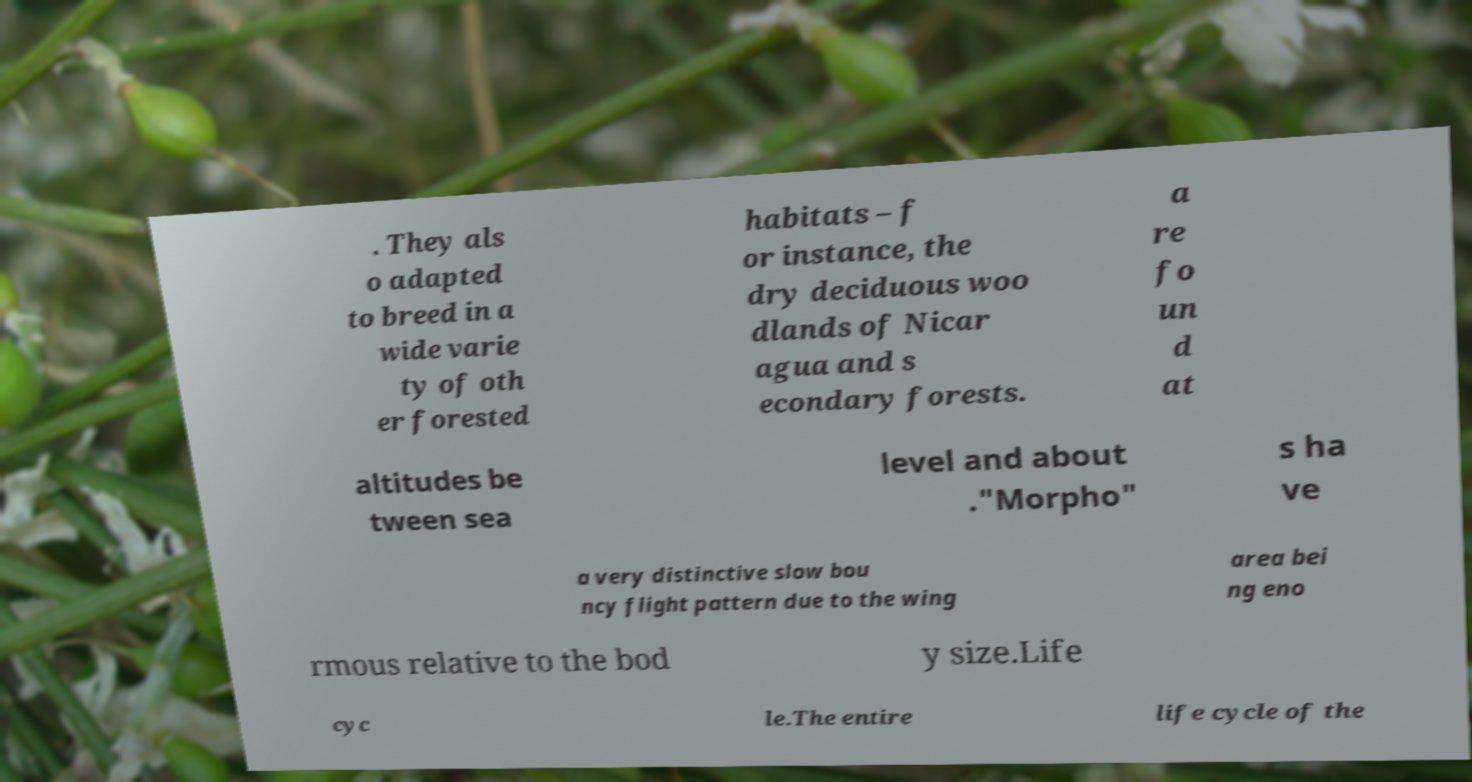Can you read and provide the text displayed in the image?This photo seems to have some interesting text. Can you extract and type it out for me? . They als o adapted to breed in a wide varie ty of oth er forested habitats – f or instance, the dry deciduous woo dlands of Nicar agua and s econdary forests. a re fo un d at altitudes be tween sea level and about ."Morpho" s ha ve a very distinctive slow bou ncy flight pattern due to the wing area bei ng eno rmous relative to the bod y size.Life cyc le.The entire life cycle of the 